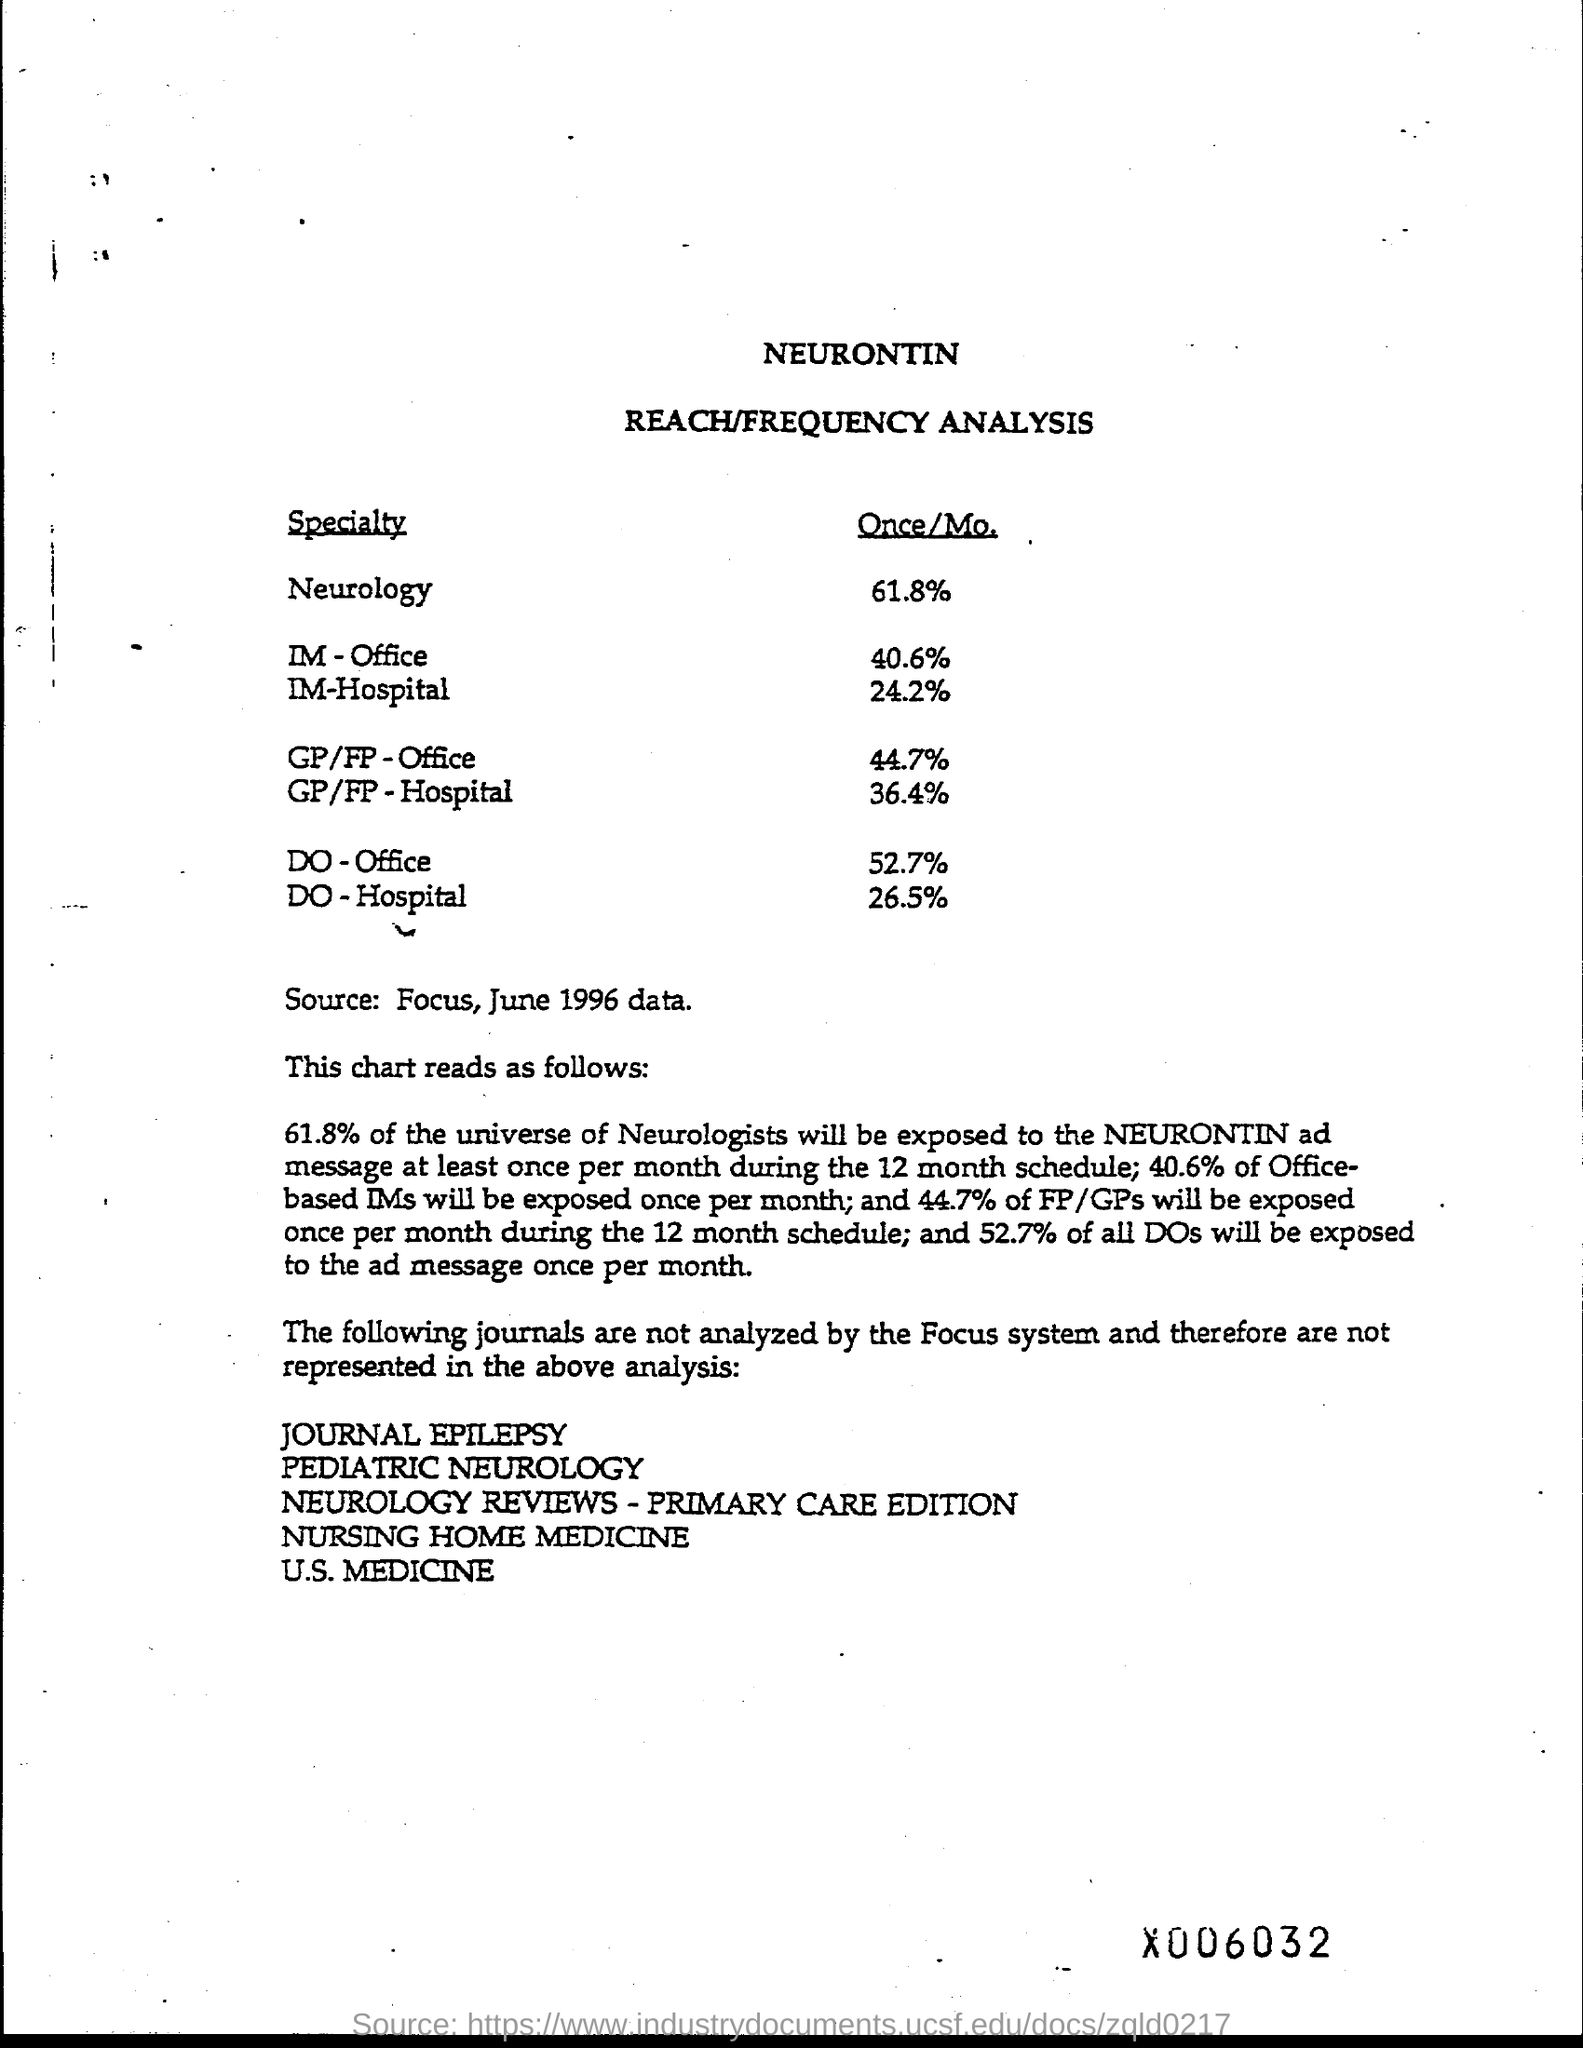Identify some key points in this picture. The source of the information is the focus magazine from June 1996, and the data used is from that time period. 